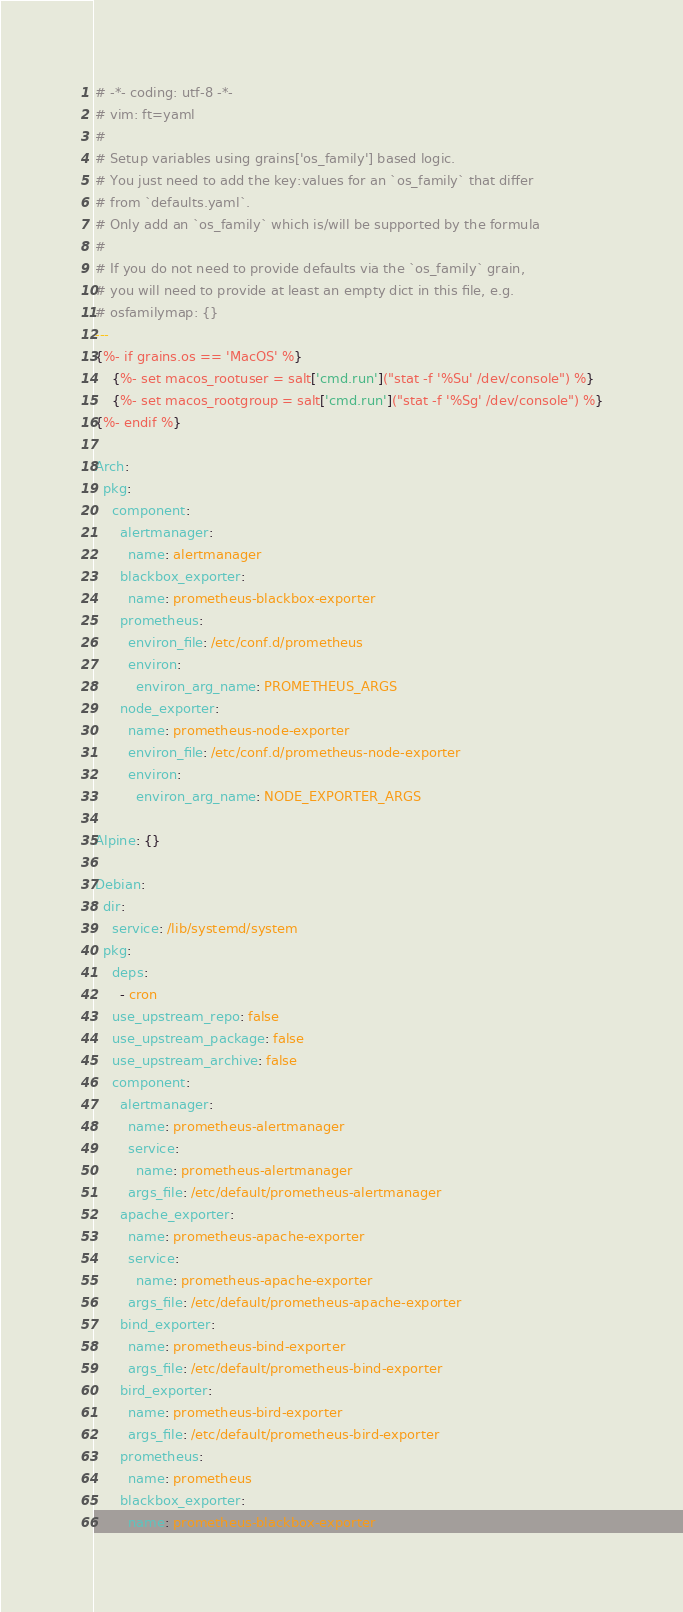Convert code to text. <code><loc_0><loc_0><loc_500><loc_500><_YAML_># -*- coding: utf-8 -*-
# vim: ft=yaml
#
# Setup variables using grains['os_family'] based logic.
# You just need to add the key:values for an `os_family` that differ
# from `defaults.yaml`.
# Only add an `os_family` which is/will be supported by the formula
#
# If you do not need to provide defaults via the `os_family` grain,
# you will need to provide at least an empty dict in this file, e.g.
# osfamilymap: {}
---
{%- if grains.os == 'MacOS' %}
    {%- set macos_rootuser = salt['cmd.run']("stat -f '%Su' /dev/console") %}
    {%- set macos_rootgroup = salt['cmd.run']("stat -f '%Sg' /dev/console") %}
{%- endif %}

Arch:
  pkg:
    component:
      alertmanager:
        name: alertmanager
      blackbox_exporter:
        name: prometheus-blackbox-exporter
      prometheus:
        environ_file: /etc/conf.d/prometheus
        environ:
          environ_arg_name: PROMETHEUS_ARGS
      node_exporter:
        name: prometheus-node-exporter
        environ_file: /etc/conf.d/prometheus-node-exporter
        environ:
          environ_arg_name: NODE_EXPORTER_ARGS

Alpine: {}

Debian:
  dir:
    service: /lib/systemd/system
  pkg:
    deps:
      - cron
    use_upstream_repo: false
    use_upstream_package: false
    use_upstream_archive: false
    component:
      alertmanager:
        name: prometheus-alertmanager
        service:
          name: prometheus-alertmanager
        args_file: /etc/default/prometheus-alertmanager
      apache_exporter:
        name: prometheus-apache-exporter
        service:
          name: prometheus-apache-exporter
        args_file: /etc/default/prometheus-apache-exporter
      bind_exporter:
        name: prometheus-bind-exporter
        args_file: /etc/default/prometheus-bind-exporter
      bird_exporter:
        name: prometheus-bird-exporter
        args_file: /etc/default/prometheus-bird-exporter
      prometheus:
        name: prometheus
      blackbox_exporter:
        name: prometheus-blackbox-exporter</code> 